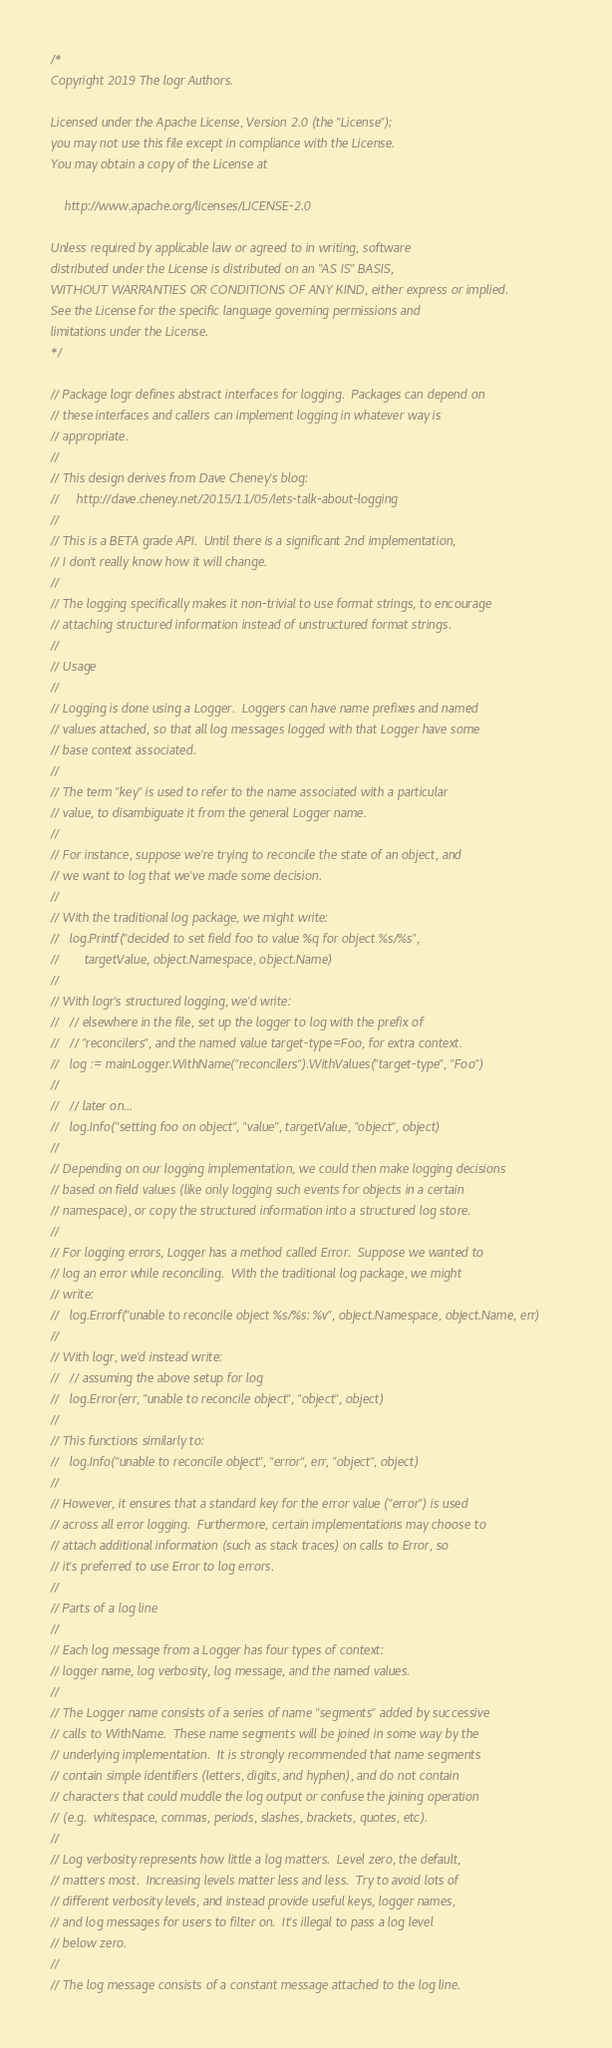<code> <loc_0><loc_0><loc_500><loc_500><_Go_>/*
Copyright 2019 The logr Authors.

Licensed under the Apache License, Version 2.0 (the "License");
you may not use this file except in compliance with the License.
You may obtain a copy of the License at

    http://www.apache.org/licenses/LICENSE-2.0

Unless required by applicable law or agreed to in writing, software
distributed under the License is distributed on an "AS IS" BASIS,
WITHOUT WARRANTIES OR CONDITIONS OF ANY KIND, either express or implied.
See the License for the specific language governing permissions and
limitations under the License.
*/

// Package logr defines abstract interfaces for logging.  Packages can depend on
// these interfaces and callers can implement logging in whatever way is
// appropriate.
//
// This design derives from Dave Cheney's blog:
//     http://dave.cheney.net/2015/11/05/lets-talk-about-logging
//
// This is a BETA grade API.  Until there is a significant 2nd implementation,
// I don't really know how it will change.
//
// The logging specifically makes it non-trivial to use format strings, to encourage
// attaching structured information instead of unstructured format strings.
//
// Usage
//
// Logging is done using a Logger.  Loggers can have name prefixes and named
// values attached, so that all log messages logged with that Logger have some
// base context associated.
//
// The term "key" is used to refer to the name associated with a particular
// value, to disambiguate it from the general Logger name.
//
// For instance, suppose we're trying to reconcile the state of an object, and
// we want to log that we've made some decision.
//
// With the traditional log package, we might write:
//   log.Printf("decided to set field foo to value %q for object %s/%s",
//       targetValue, object.Namespace, object.Name)
//
// With logr's structured logging, we'd write:
//   // elsewhere in the file, set up the logger to log with the prefix of
//   // "reconcilers", and the named value target-type=Foo, for extra context.
//   log := mainLogger.WithName("reconcilers").WithValues("target-type", "Foo")
//
//   // later on...
//   log.Info("setting foo on object", "value", targetValue, "object", object)
//
// Depending on our logging implementation, we could then make logging decisions
// based on field values (like only logging such events for objects in a certain
// namespace), or copy the structured information into a structured log store.
//
// For logging errors, Logger has a method called Error.  Suppose we wanted to
// log an error while reconciling.  With the traditional log package, we might
// write:
//   log.Errorf("unable to reconcile object %s/%s: %v", object.Namespace, object.Name, err)
//
// With logr, we'd instead write:
//   // assuming the above setup for log
//   log.Error(err, "unable to reconcile object", "object", object)
//
// This functions similarly to:
//   log.Info("unable to reconcile object", "error", err, "object", object)
//
// However, it ensures that a standard key for the error value ("error") is used
// across all error logging.  Furthermore, certain implementations may choose to
// attach additional information (such as stack traces) on calls to Error, so
// it's preferred to use Error to log errors.
//
// Parts of a log line
//
// Each log message from a Logger has four types of context:
// logger name, log verbosity, log message, and the named values.
//
// The Logger name consists of a series of name "segments" added by successive
// calls to WithName.  These name segments will be joined in some way by the
// underlying implementation.  It is strongly recommended that name segments
// contain simple identifiers (letters, digits, and hyphen), and do not contain
// characters that could muddle the log output or confuse the joining operation
// (e.g.  whitespace, commas, periods, slashes, brackets, quotes, etc).
//
// Log verbosity represents how little a log matters.  Level zero, the default,
// matters most.  Increasing levels matter less and less.  Try to avoid lots of
// different verbosity levels, and instead provide useful keys, logger names,
// and log messages for users to filter on.  It's illegal to pass a log level
// below zero.
//
// The log message consists of a constant message attached to the log line.</code> 